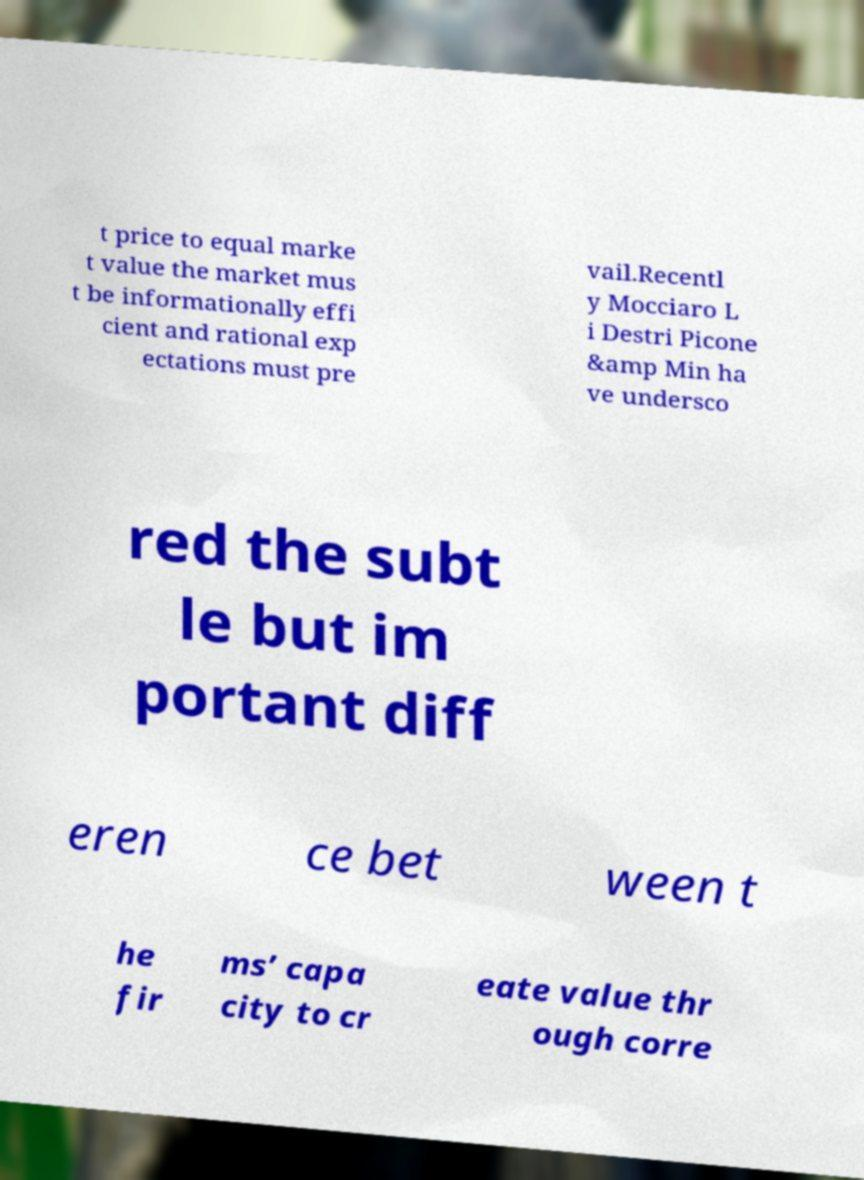Please identify and transcribe the text found in this image. t price to equal marke t value the market mus t be informationally effi cient and rational exp ectations must pre vail.Recentl y Mocciaro L i Destri Picone &amp Min ha ve undersco red the subt le but im portant diff eren ce bet ween t he fir ms’ capa city to cr eate value thr ough corre 